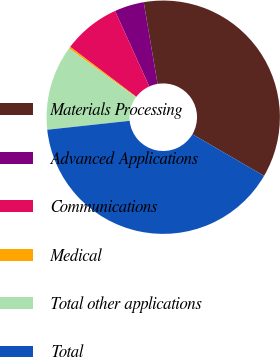<chart> <loc_0><loc_0><loc_500><loc_500><pie_chart><fcel>Materials Processing<fcel>Advanced Applications<fcel>Communications<fcel>Medical<fcel>Total other applications<fcel>Total<nl><fcel>36.07%<fcel>4.1%<fcel>7.92%<fcel>0.27%<fcel>11.75%<fcel>39.9%<nl></chart> 